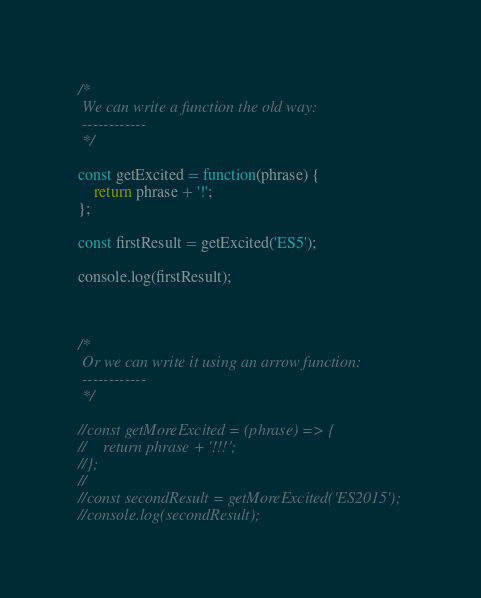<code> <loc_0><loc_0><loc_500><loc_500><_JavaScript_>/*
 We can write a function the old way:
 ------------
 */

const getExcited = function(phrase) {
    return phrase + '!';
};

const firstResult = getExcited('ES5');

console.log(firstResult);



/*
 Or we can write it using an arrow function:
 ------------
 */

//const getMoreExcited = (phrase) => {
//    return phrase + '!!!';
//};
//
//const secondResult = getMoreExcited('ES2015');
//console.log(secondResult);</code> 